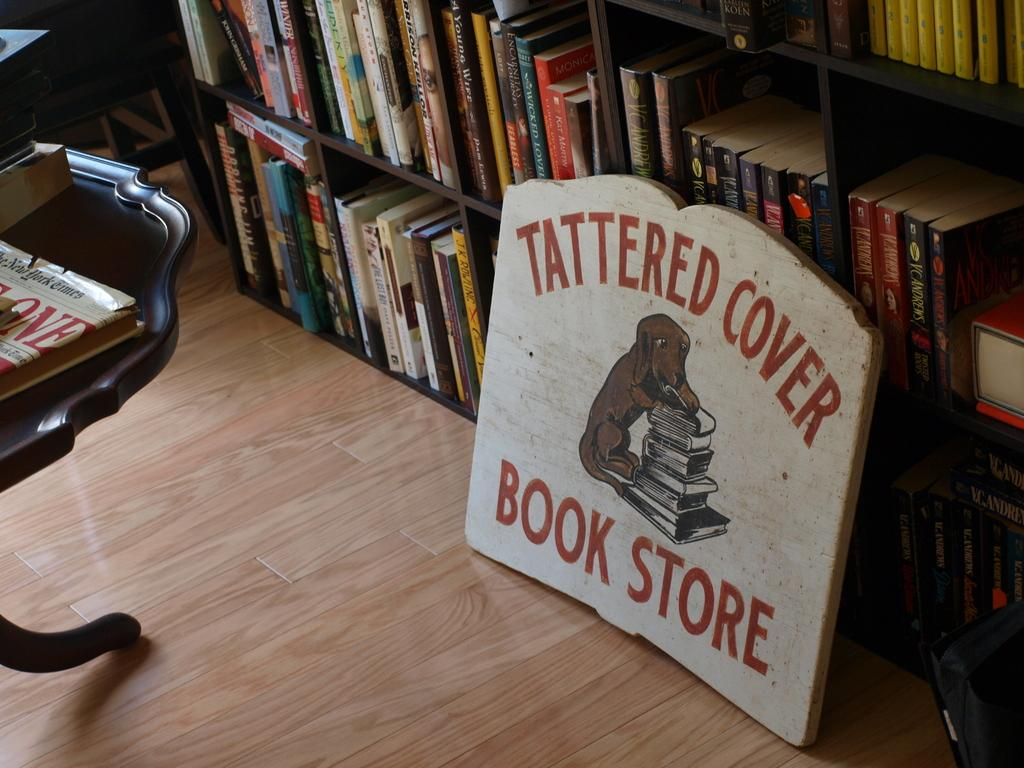<image>
Present a compact description of the photo's key features. A white sign that says Tattered Cover Book Store is leaning on a shelf of books. 